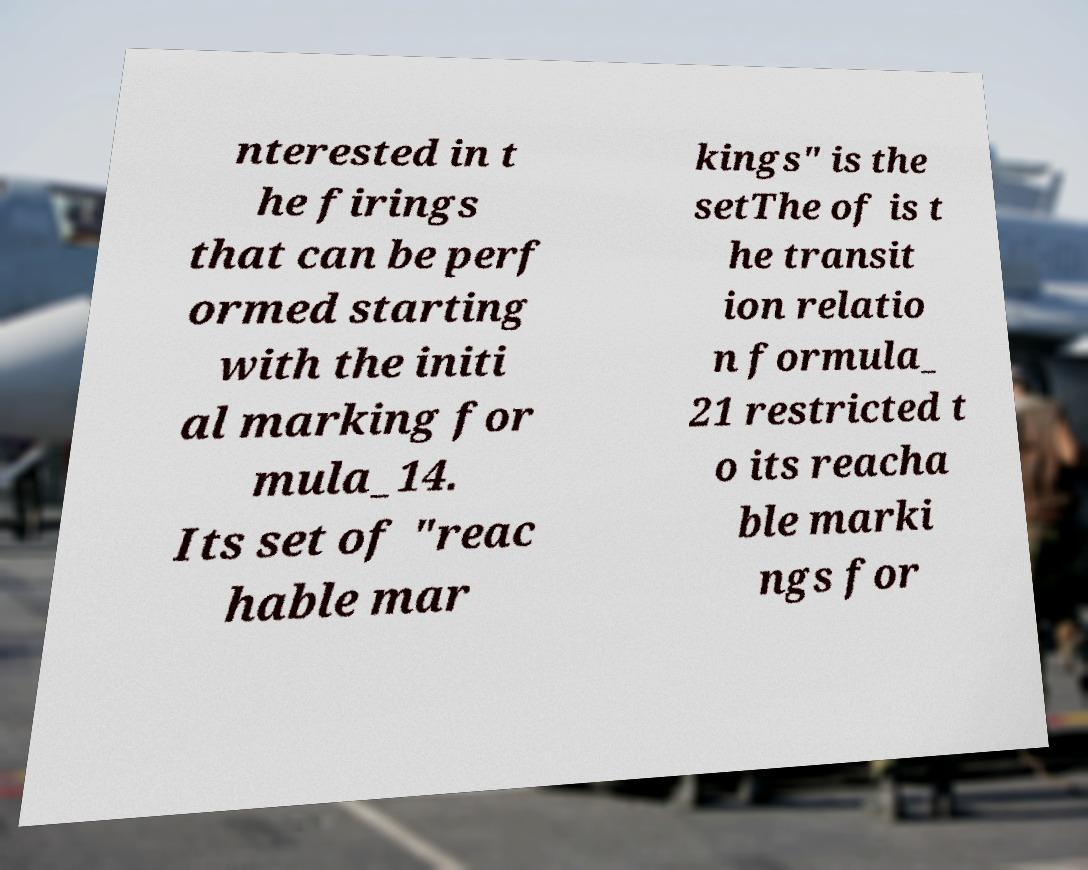Can you read and provide the text displayed in the image?This photo seems to have some interesting text. Can you extract and type it out for me? nterested in t he firings that can be perf ormed starting with the initi al marking for mula_14. Its set of "reac hable mar kings" is the setThe of is t he transit ion relatio n formula_ 21 restricted t o its reacha ble marki ngs for 